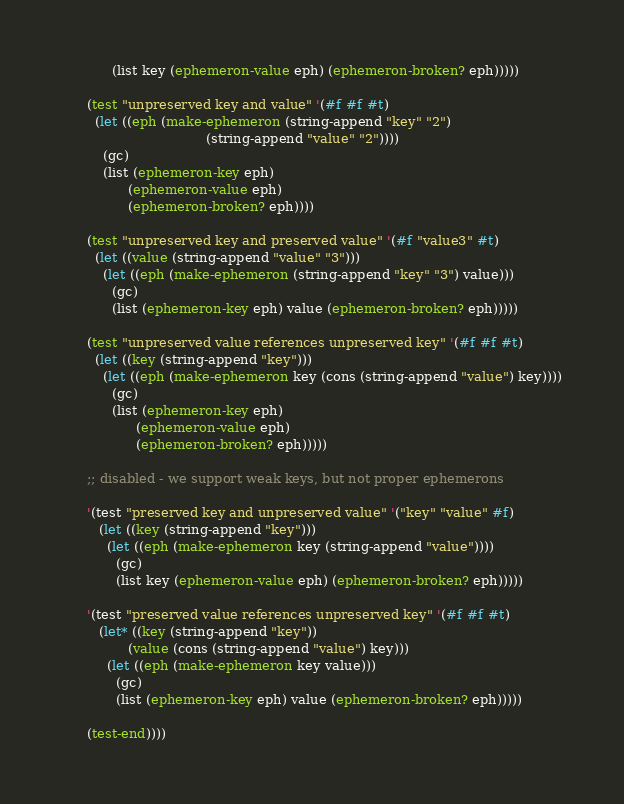Convert code to text. <code><loc_0><loc_0><loc_500><loc_500><_Scheme_>            (list key (ephemeron-value eph) (ephemeron-broken? eph)))))

      (test "unpreserved key and value" '(#f #f #t)
        (let ((eph (make-ephemeron (string-append "key" "2")
                                   (string-append "value" "2"))))
          (gc)
          (list (ephemeron-key eph)
                (ephemeron-value eph)
                (ephemeron-broken? eph))))

      (test "unpreserved key and preserved value" '(#f "value3" #t)
        (let ((value (string-append "value" "3")))
          (let ((eph (make-ephemeron (string-append "key" "3") value)))
            (gc)
            (list (ephemeron-key eph) value (ephemeron-broken? eph)))))

      (test "unpreserved value references unpreserved key" '(#f #f #t)
        (let ((key (string-append "key")))
          (let ((eph (make-ephemeron key (cons (string-append "value") key))))
            (gc)
            (list (ephemeron-key eph)
                  (ephemeron-value eph)
                  (ephemeron-broken? eph)))))

      ;; disabled - we support weak keys, but not proper ephemerons

      '(test "preserved key and unpreserved value" '("key" "value" #f)
         (let ((key (string-append "key")))
           (let ((eph (make-ephemeron key (string-append "value"))))
             (gc)
             (list key (ephemeron-value eph) (ephemeron-broken? eph)))))

      '(test "preserved value references unpreserved key" '(#f #f #t)
         (let* ((key (string-append "key"))
                (value (cons (string-append "value") key)))
           (let ((eph (make-ephemeron key value)))
             (gc)
             (list (ephemeron-key eph) value (ephemeron-broken? eph)))))

      (test-end))))
</code> 